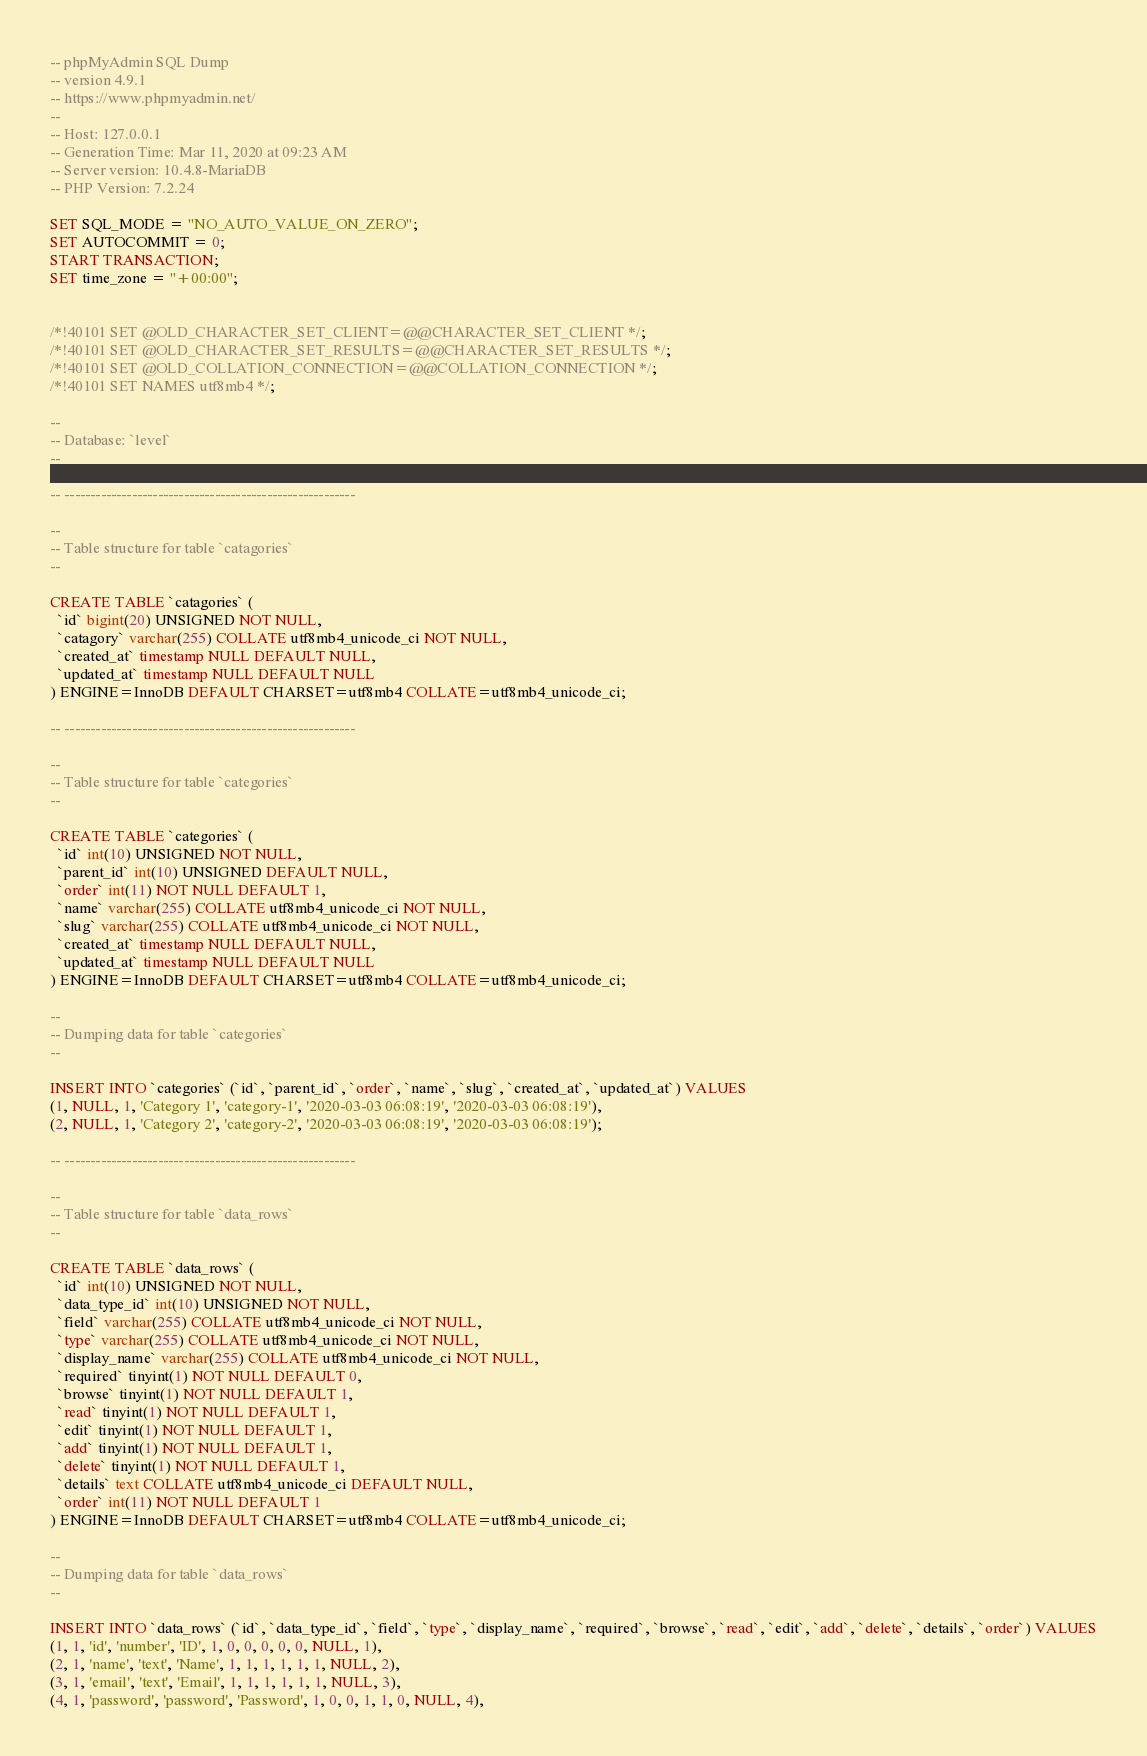Convert code to text. <code><loc_0><loc_0><loc_500><loc_500><_SQL_>-- phpMyAdmin SQL Dump
-- version 4.9.1
-- https://www.phpmyadmin.net/
--
-- Host: 127.0.0.1
-- Generation Time: Mar 11, 2020 at 09:23 AM
-- Server version: 10.4.8-MariaDB
-- PHP Version: 7.2.24

SET SQL_MODE = "NO_AUTO_VALUE_ON_ZERO";
SET AUTOCOMMIT = 0;
START TRANSACTION;
SET time_zone = "+00:00";


/*!40101 SET @OLD_CHARACTER_SET_CLIENT=@@CHARACTER_SET_CLIENT */;
/*!40101 SET @OLD_CHARACTER_SET_RESULTS=@@CHARACTER_SET_RESULTS */;
/*!40101 SET @OLD_COLLATION_CONNECTION=@@COLLATION_CONNECTION */;
/*!40101 SET NAMES utf8mb4 */;

--
-- Database: `level`
--

-- --------------------------------------------------------

--
-- Table structure for table `catagories`
--

CREATE TABLE `catagories` (
  `id` bigint(20) UNSIGNED NOT NULL,
  `catagory` varchar(255) COLLATE utf8mb4_unicode_ci NOT NULL,
  `created_at` timestamp NULL DEFAULT NULL,
  `updated_at` timestamp NULL DEFAULT NULL
) ENGINE=InnoDB DEFAULT CHARSET=utf8mb4 COLLATE=utf8mb4_unicode_ci;

-- --------------------------------------------------------

--
-- Table structure for table `categories`
--

CREATE TABLE `categories` (
  `id` int(10) UNSIGNED NOT NULL,
  `parent_id` int(10) UNSIGNED DEFAULT NULL,
  `order` int(11) NOT NULL DEFAULT 1,
  `name` varchar(255) COLLATE utf8mb4_unicode_ci NOT NULL,
  `slug` varchar(255) COLLATE utf8mb4_unicode_ci NOT NULL,
  `created_at` timestamp NULL DEFAULT NULL,
  `updated_at` timestamp NULL DEFAULT NULL
) ENGINE=InnoDB DEFAULT CHARSET=utf8mb4 COLLATE=utf8mb4_unicode_ci;

--
-- Dumping data for table `categories`
--

INSERT INTO `categories` (`id`, `parent_id`, `order`, `name`, `slug`, `created_at`, `updated_at`) VALUES
(1, NULL, 1, 'Category 1', 'category-1', '2020-03-03 06:08:19', '2020-03-03 06:08:19'),
(2, NULL, 1, 'Category 2', 'category-2', '2020-03-03 06:08:19', '2020-03-03 06:08:19');

-- --------------------------------------------------------

--
-- Table structure for table `data_rows`
--

CREATE TABLE `data_rows` (
  `id` int(10) UNSIGNED NOT NULL,
  `data_type_id` int(10) UNSIGNED NOT NULL,
  `field` varchar(255) COLLATE utf8mb4_unicode_ci NOT NULL,
  `type` varchar(255) COLLATE utf8mb4_unicode_ci NOT NULL,
  `display_name` varchar(255) COLLATE utf8mb4_unicode_ci NOT NULL,
  `required` tinyint(1) NOT NULL DEFAULT 0,
  `browse` tinyint(1) NOT NULL DEFAULT 1,
  `read` tinyint(1) NOT NULL DEFAULT 1,
  `edit` tinyint(1) NOT NULL DEFAULT 1,
  `add` tinyint(1) NOT NULL DEFAULT 1,
  `delete` tinyint(1) NOT NULL DEFAULT 1,
  `details` text COLLATE utf8mb4_unicode_ci DEFAULT NULL,
  `order` int(11) NOT NULL DEFAULT 1
) ENGINE=InnoDB DEFAULT CHARSET=utf8mb4 COLLATE=utf8mb4_unicode_ci;

--
-- Dumping data for table `data_rows`
--

INSERT INTO `data_rows` (`id`, `data_type_id`, `field`, `type`, `display_name`, `required`, `browse`, `read`, `edit`, `add`, `delete`, `details`, `order`) VALUES
(1, 1, 'id', 'number', 'ID', 1, 0, 0, 0, 0, 0, NULL, 1),
(2, 1, 'name', 'text', 'Name', 1, 1, 1, 1, 1, 1, NULL, 2),
(3, 1, 'email', 'text', 'Email', 1, 1, 1, 1, 1, 1, NULL, 3),
(4, 1, 'password', 'password', 'Password', 1, 0, 0, 1, 1, 0, NULL, 4),</code> 